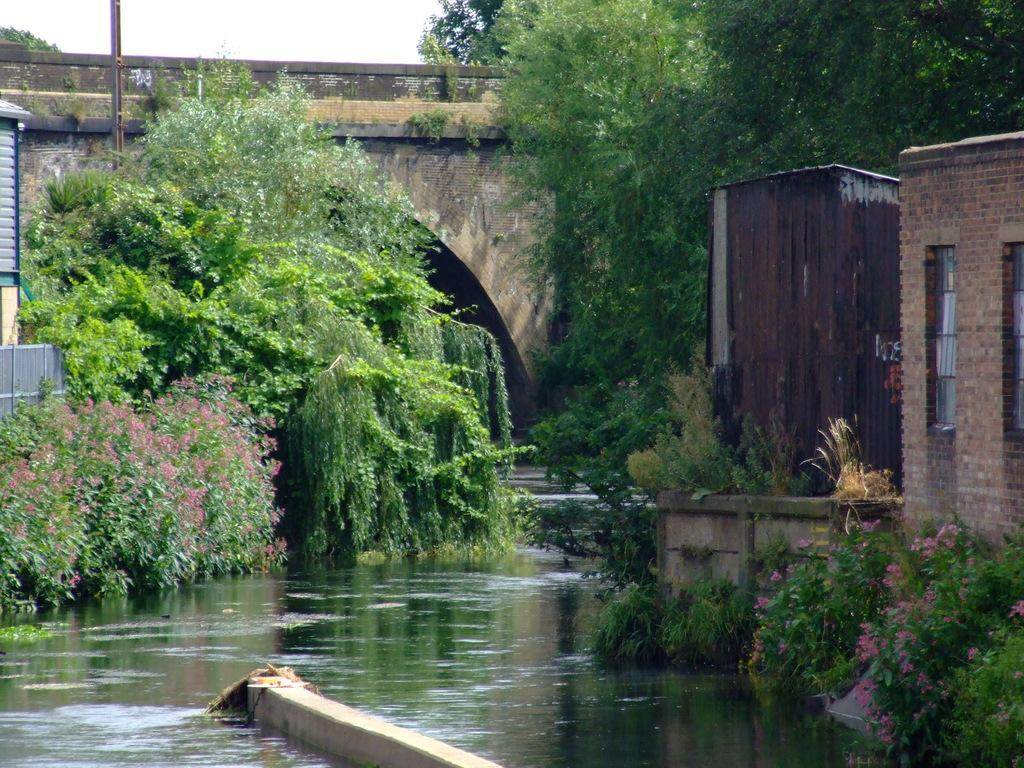What is the primary element visible in the image? There is water in the image. What other natural elements can be seen in the image? There are plants and trees in the image. What type of structure is present in the image? There is a bridge in the image. What is visible at the top of the image? The sky is clear and visible at the top of the image. What type of silk is being used to make the ducks fly in the image? There are no ducks or silk present in the image. What is the afterthought in the image? There is no specific afterthought mentioned or depicted in the image. 